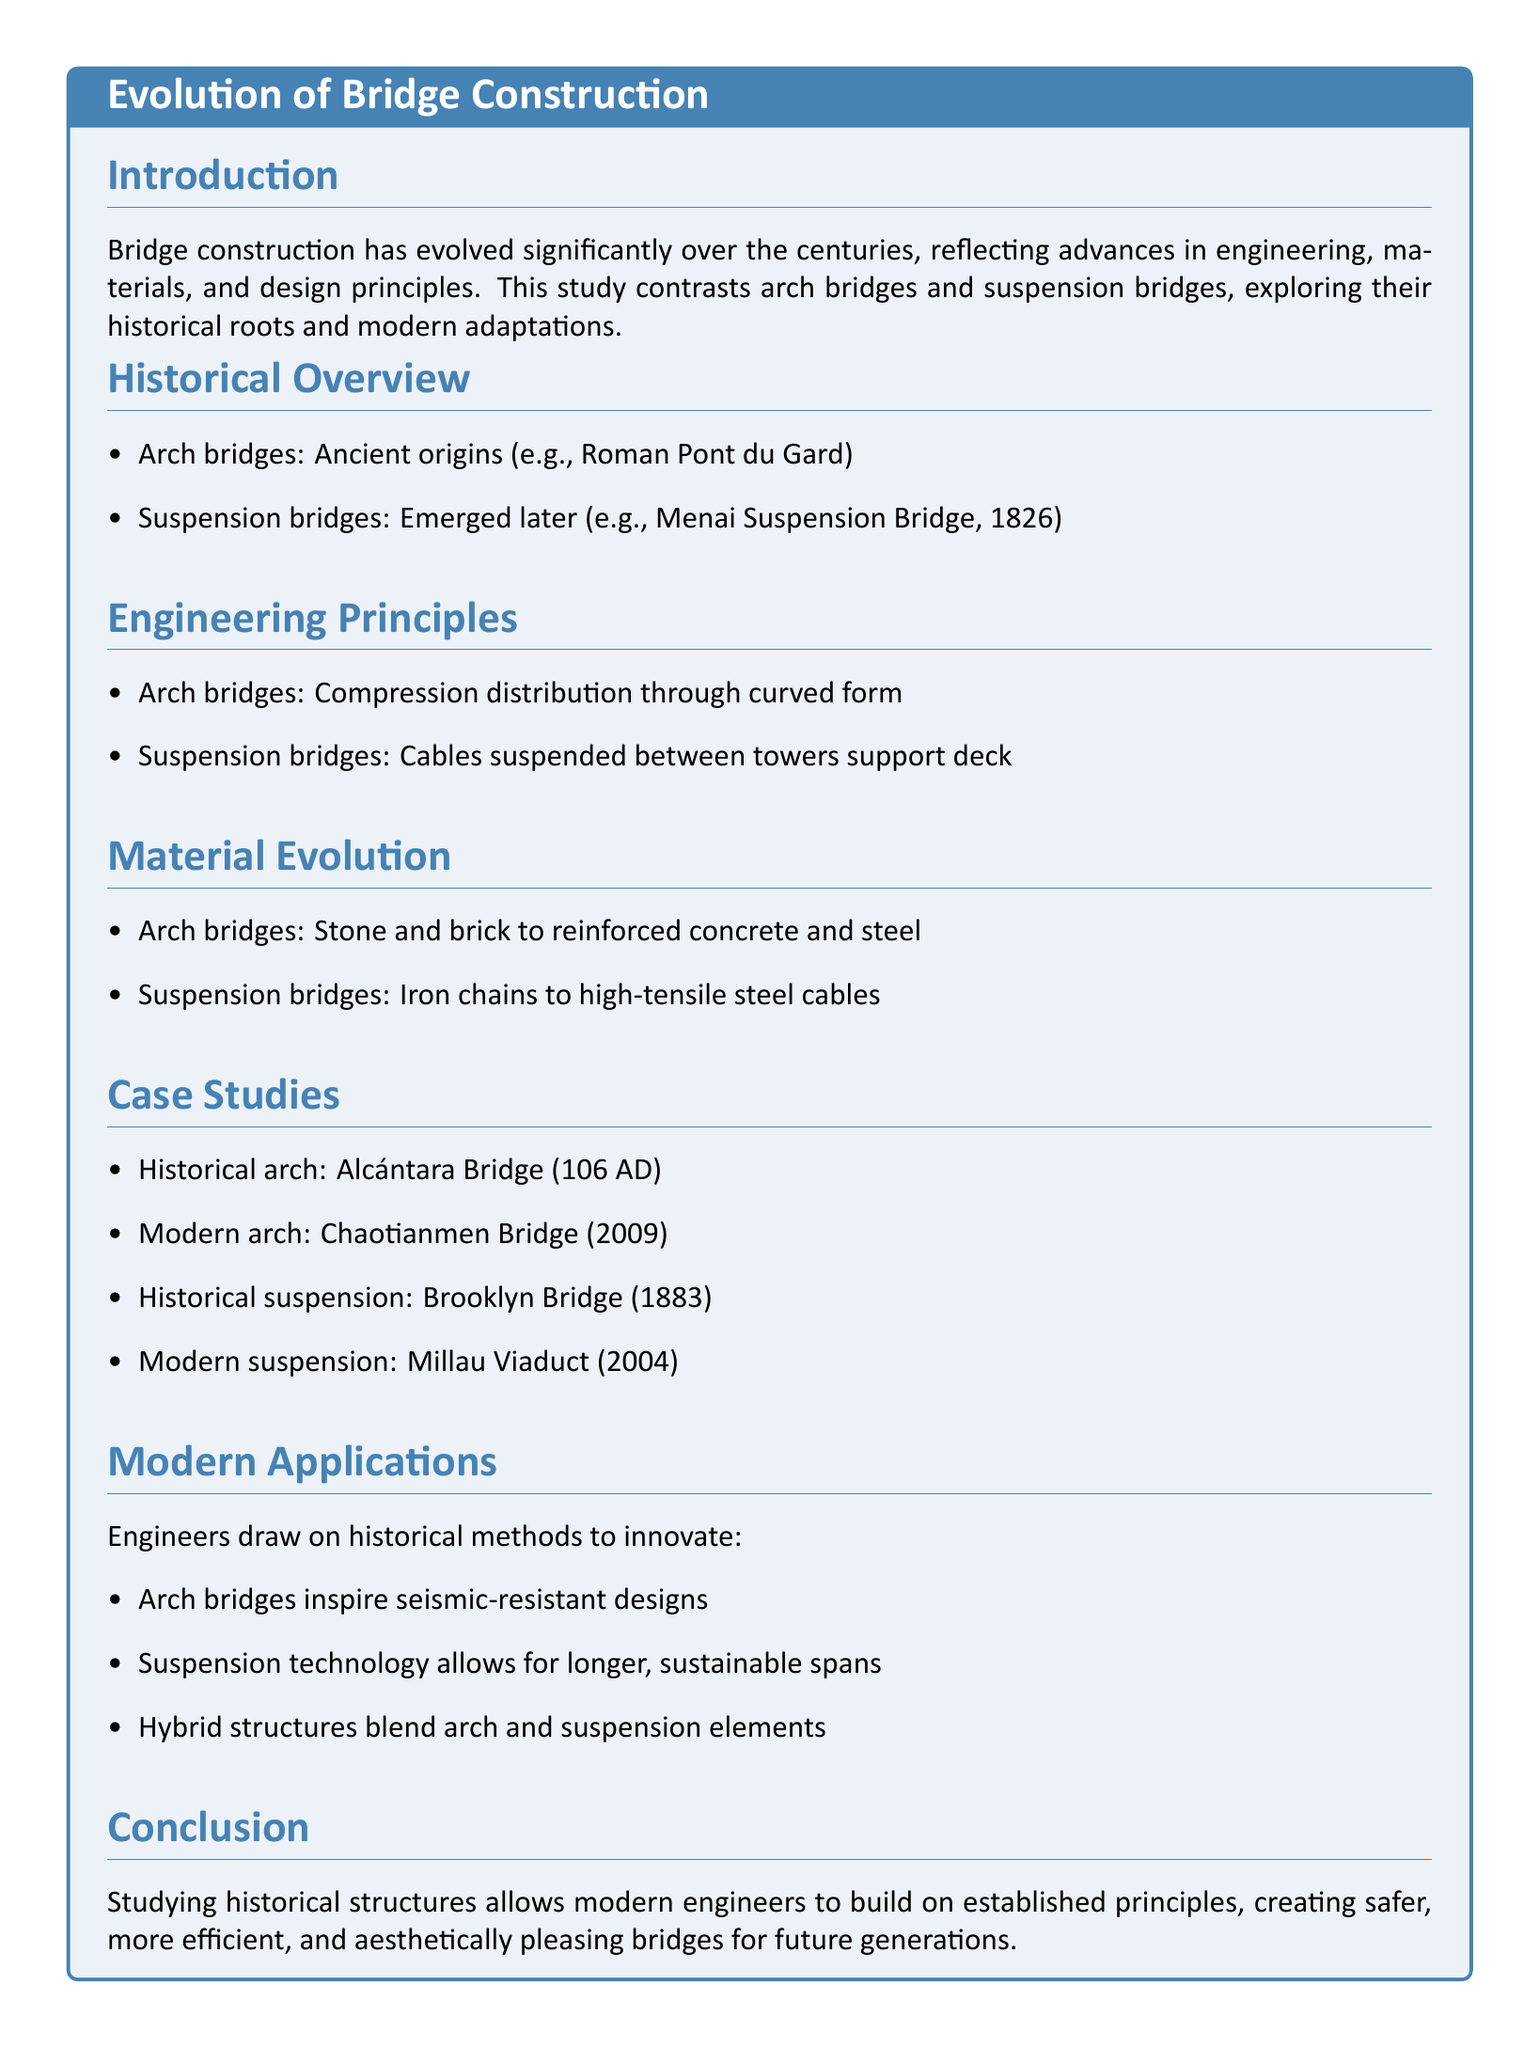What are the ancient origins of arch bridges? The document mentions the Roman Pont du Gard as an example of ancient origins of arch bridges.
Answer: Roman Pont du Gard When did the Menai Suspension Bridge emerge? The document states that the Menai Suspension Bridge emerged in 1826.
Answer: 1826 What material has evolved from stone and brick in arch bridges? The document indicates that arch bridges' materials have evolved to include reinforced concrete and steel.
Answer: Reinforced concrete and steel Which modern arch bridge is mentioned in the document? The Chaotianmen Bridge, completed in 2009, is identified as a modern arch bridge in the document.
Answer: Chaotianmen Bridge What type of cables are used in modern suspension bridges? According to the document, modern suspension bridges use high-tensile steel cables.
Answer: High-tensile steel cables How do arch bridges inspire modern designs? The document states that arch bridges inspire seismic-resistant designs in modern applications.
Answer: Seismic-resistant designs What is a hybrid structure? The document refers to hybrid structures as those that blend arch and suspension elements.
Answer: Blend of arch and suspension elements What historical arch bridge is mentioned? The Alcántara Bridge, dating back to 106 AD, is mentioned as a historical arch bridge.
Answer: Alcántara Bridge What year was the Brooklyn Bridge completed? The document mentions that the Brooklyn Bridge was completed in 1883.
Answer: 1883 